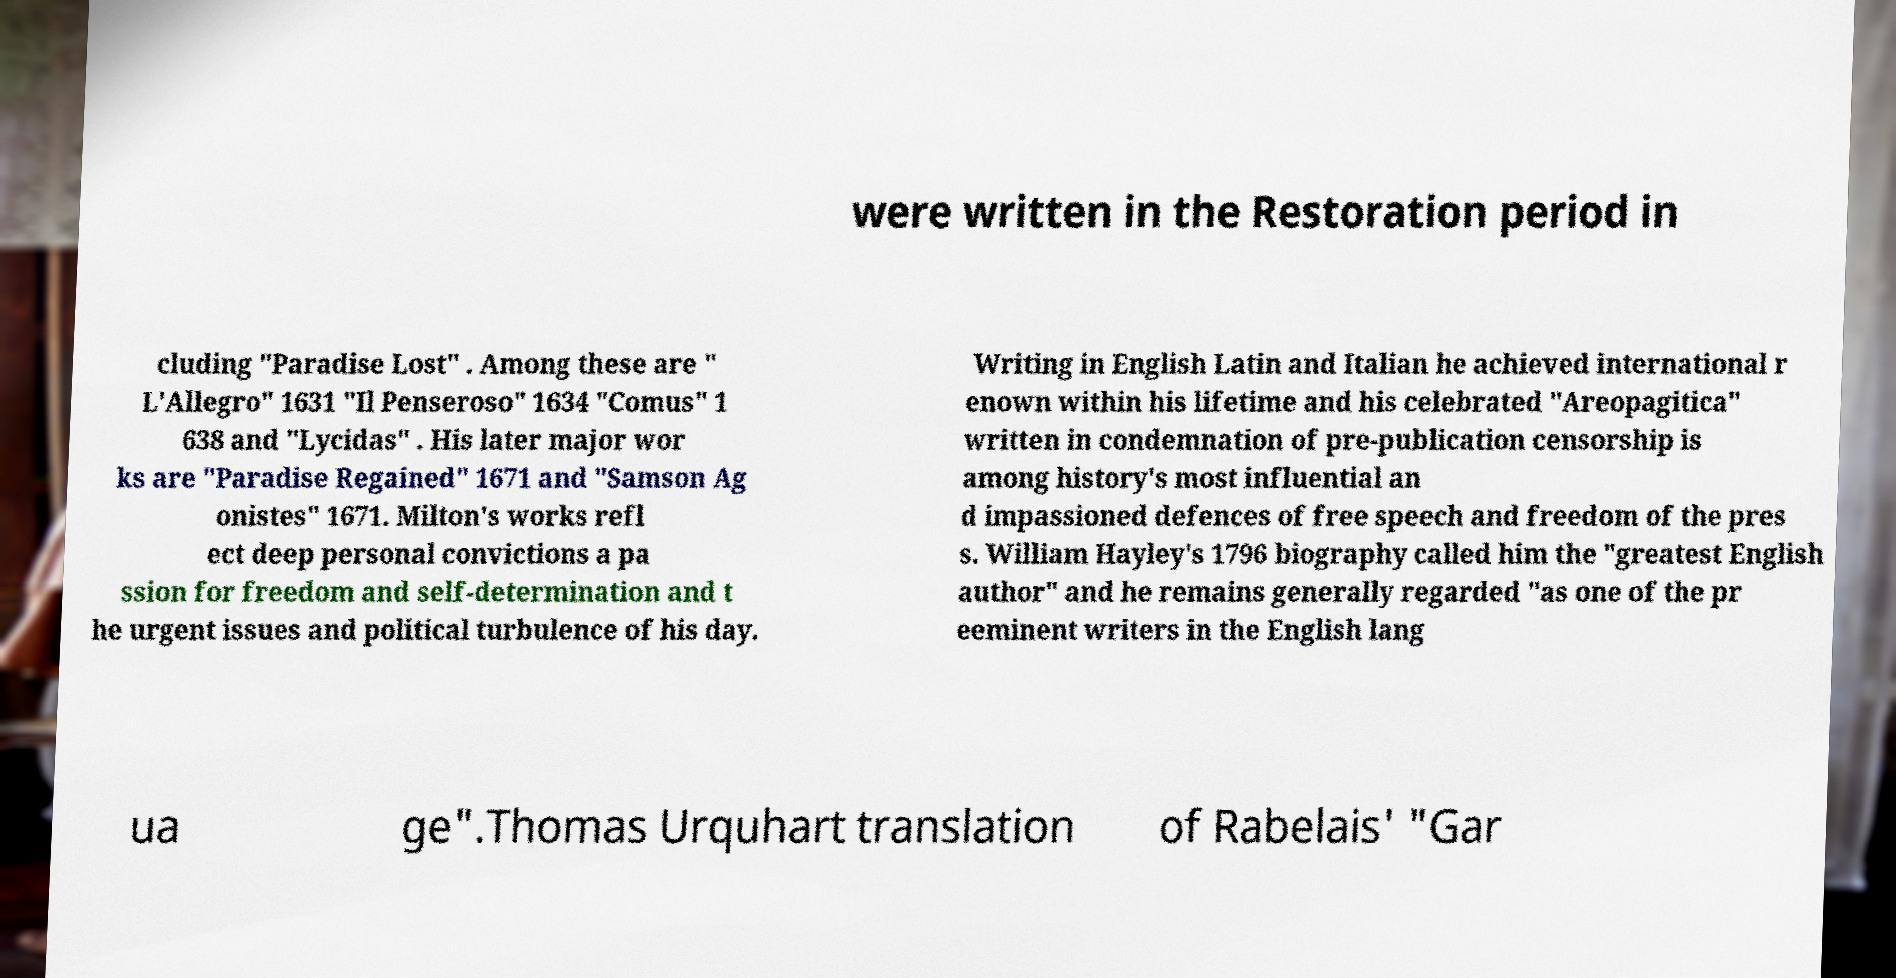Can you read and provide the text displayed in the image?This photo seems to have some interesting text. Can you extract and type it out for me? were written in the Restoration period in cluding "Paradise Lost" . Among these are " L'Allegro" 1631 "Il Penseroso" 1634 "Comus" 1 638 and "Lycidas" . His later major wor ks are "Paradise Regained" 1671 and "Samson Ag onistes" 1671. Milton's works refl ect deep personal convictions a pa ssion for freedom and self-determination and t he urgent issues and political turbulence of his day. Writing in English Latin and Italian he achieved international r enown within his lifetime and his celebrated "Areopagitica" written in condemnation of pre-publication censorship is among history's most influential an d impassioned defences of free speech and freedom of the pres s. William Hayley's 1796 biography called him the "greatest English author" and he remains generally regarded "as one of the pr eeminent writers in the English lang ua ge".Thomas Urquhart translation of Rabelais' "Gar 